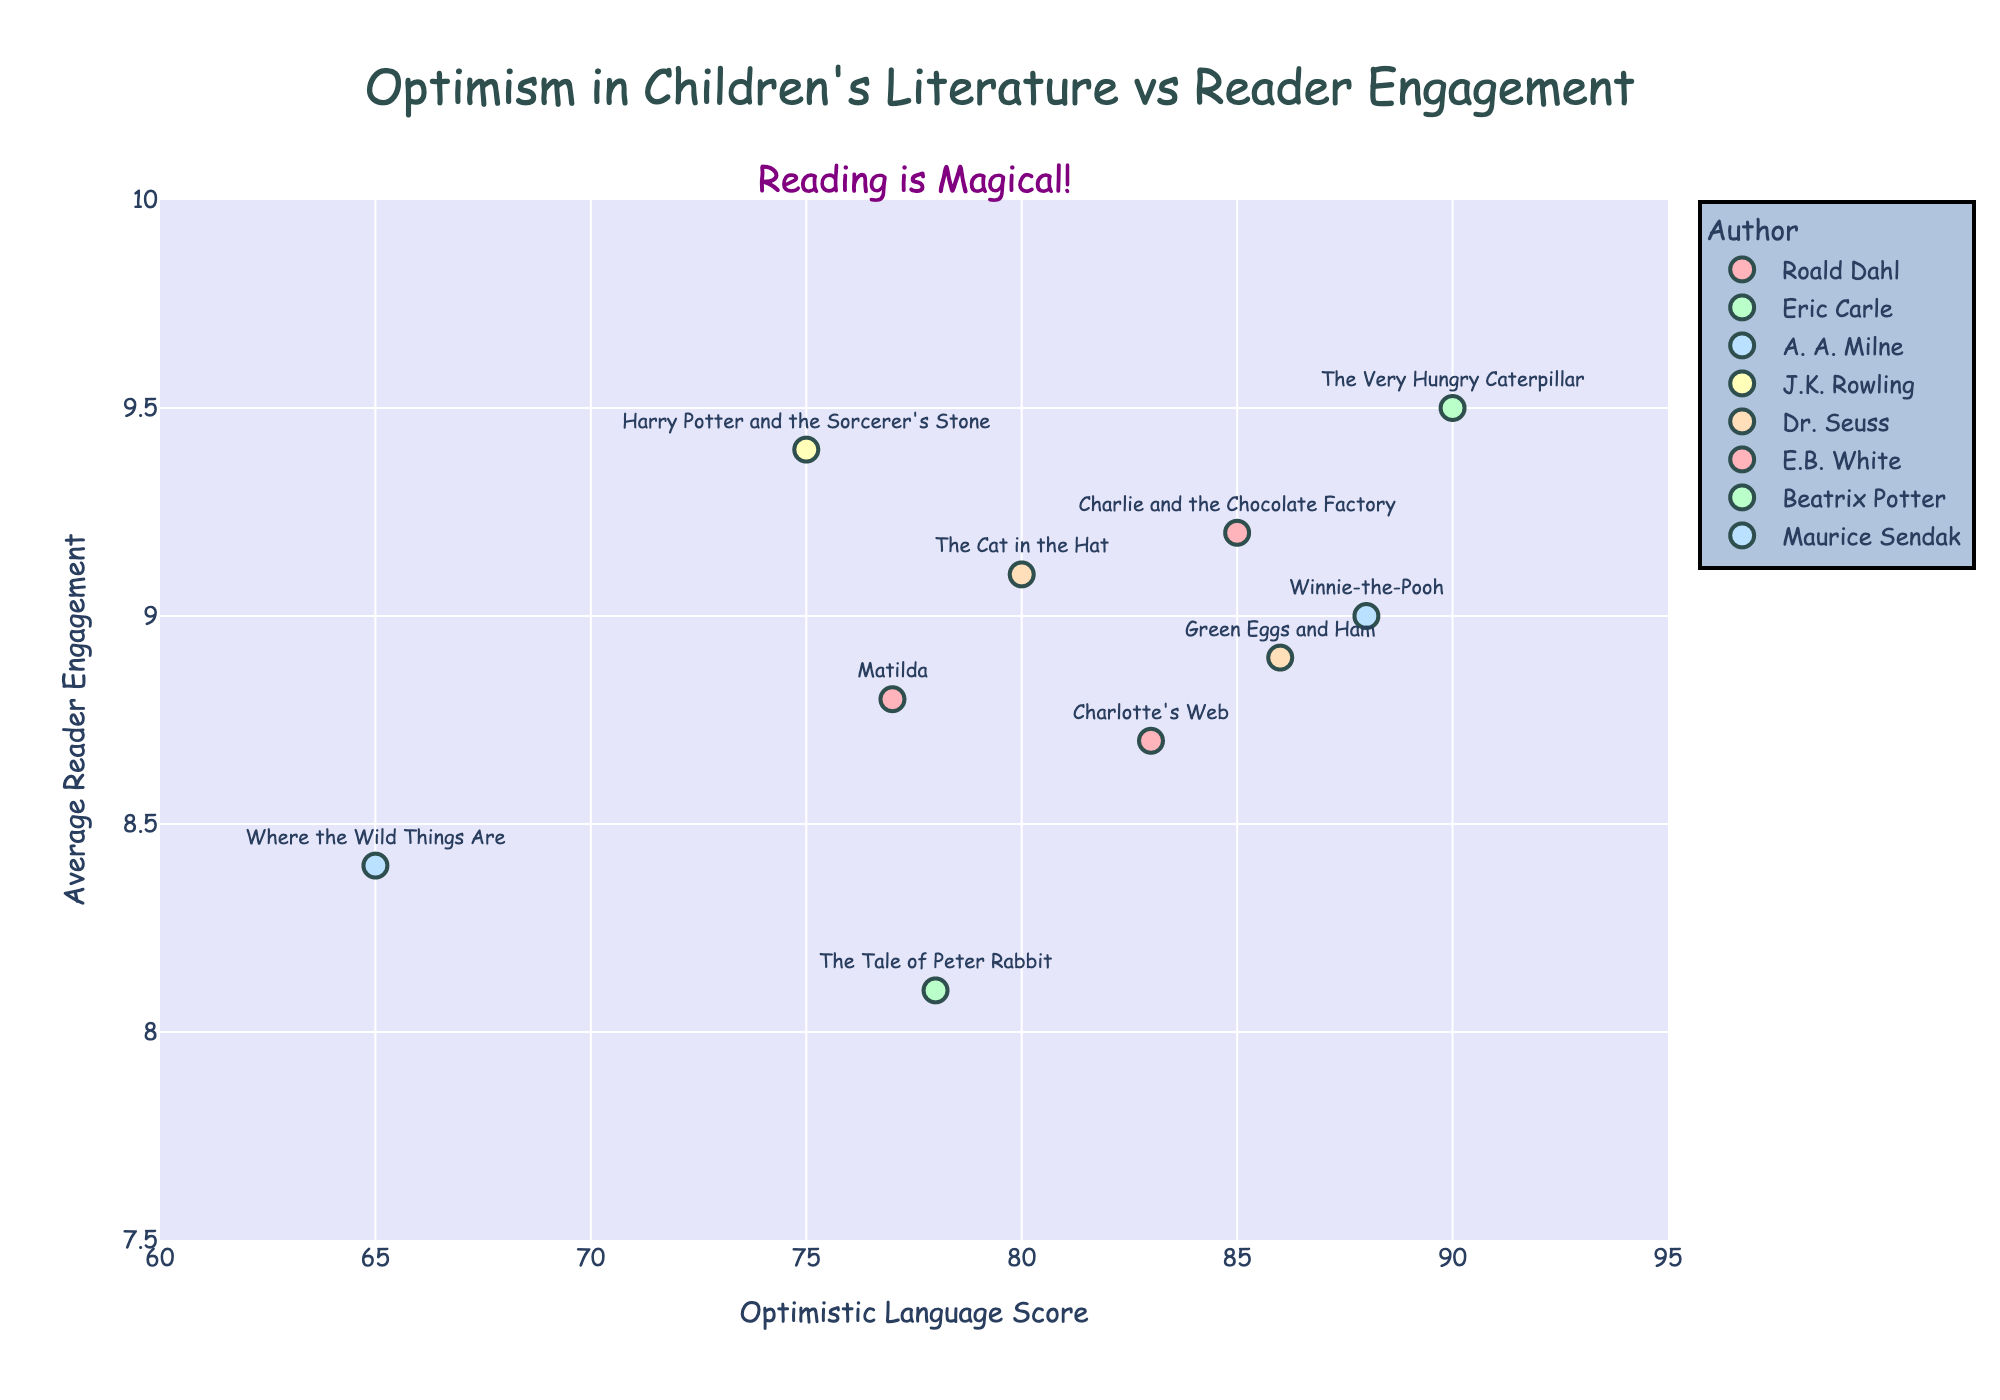What is the title of the plot? The title is at the top of the plot and reads, "Optimism in Children's Literature vs Reader Engagement".
Answer: "Optimism in Children's Literature vs Reader Engagement" What are the ranges of the x-axis and y-axis? The x-axis ranges from 60 to 95, and the y-axis ranges from 7.5 to 10. These ranges are visible on the axes labels.
Answer: x-axis: 60 to 95, y-axis: 7.5 to 10 How many books by Roald Dahl are in the scatter plot? There are two books by Roald Dahl in the plot, which are "Charlie and the Chocolate Factory" and "Matilda". These books are marked by the same color in the legend.
Answer: 2 Which book has the highest reader engagement score? "The Very Hungry Caterpillar" by Eric Carle has the highest reader engagement score of 9.5, visible by its position highest on the plot's y-axis.
Answer: "The Very Hungry Caterpillar" What is the optimistic language score of "Harry Potter and the Sorcerer's Stone"? The optimistic language score for "Harry Potter and the Sorcerer's Stone" can be read directly from the position on the x-axis, which is 75.
Answer: 75 Which author has the most books in this plot? Based on the color coding and scatter plot, Dr. Seuss has the most books with "The Cat in the Hat" and "Green Eggs and Ham".
Answer: Dr. Seuss What is the average optimistic language score of Roald Dahl's books in the plot? Roald Dahl's books have scores of 85 and 77. To find the average: (85 + 77) / 2 = 81.
Answer: 81 Calculate the average reader engagement level for books with an optimistic language score higher than 80. There are five books with optimistic language scores higher than 80: "Charlie and the Chocolate Factory" (9.2), "The Very Hungry Caterpillar" (9.5), "Winnie-the-Pooh" (9.0), "Charlotte's Web" (8.7), and "Green Eggs and Ham" (8.9). Average = (9.2 + 9.5 + 9.0 + 8.7 + 8.9) / 5 = 9.06.
Answer: 9.06 Which book by Beatrix Potter appears in the plot, and what is its reader engagement score? "The Tale of Peter Rabbit" by Beatrix Potter has a reader engagement score of 8.1, according to its position on the y-axis.
Answer: "The Tale of Peter Rabbit", 8.1 Is there a general trend between the optimistic language score and reader engagement level in these books? The scatter plot indicates a positive trend where higher optimistic language scores correlate with higher reader engagement levels, though this trend has exceptions and isn't strictly linear.
Answer: Yes, positive trend 